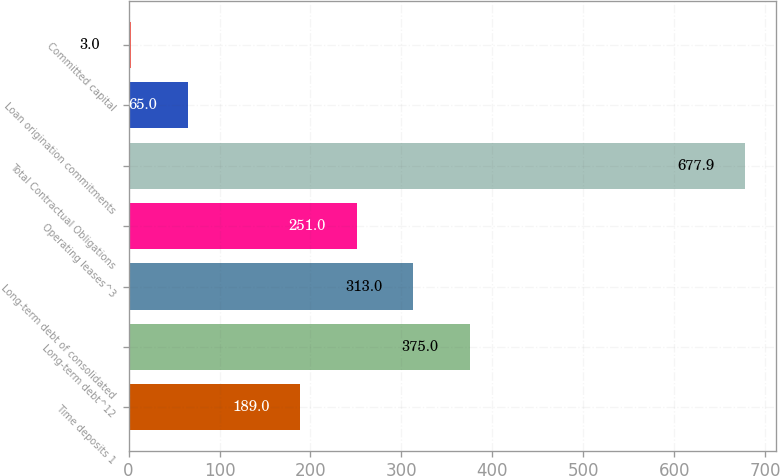Convert chart to OTSL. <chart><loc_0><loc_0><loc_500><loc_500><bar_chart><fcel>Time deposits 1<fcel>Long-term debt^12<fcel>Long-term debt of consolidated<fcel>Operating leases^3<fcel>Total Contractual Obligations<fcel>Loan origination commitments<fcel>Committed capital<nl><fcel>189<fcel>375<fcel>313<fcel>251<fcel>677.9<fcel>65<fcel>3<nl></chart> 